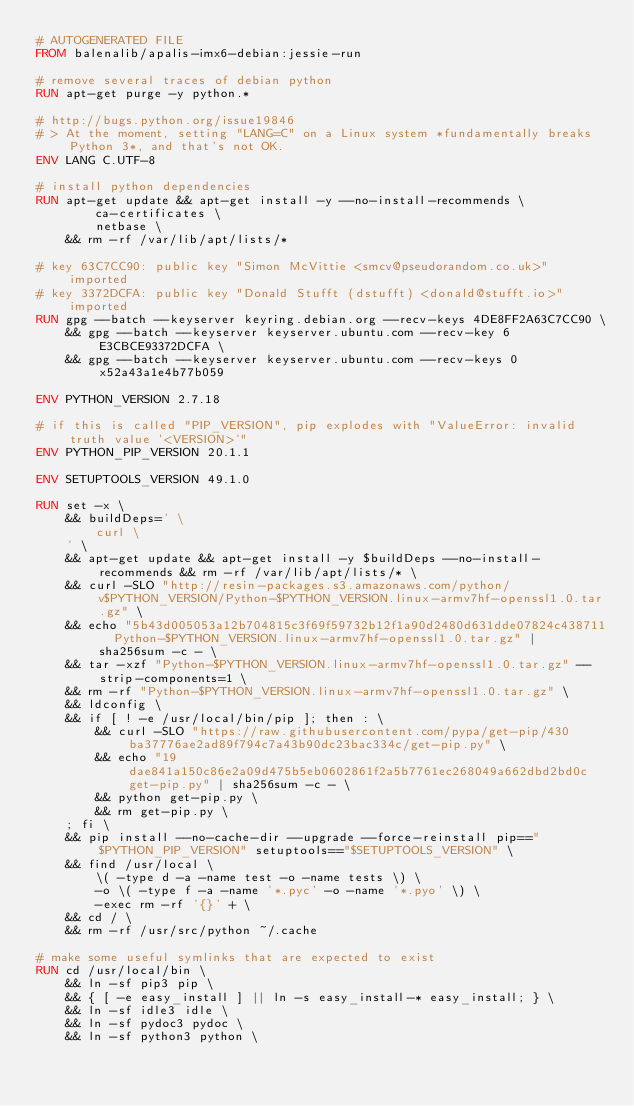Convert code to text. <code><loc_0><loc_0><loc_500><loc_500><_Dockerfile_># AUTOGENERATED FILE
FROM balenalib/apalis-imx6-debian:jessie-run

# remove several traces of debian python
RUN apt-get purge -y python.*

# http://bugs.python.org/issue19846
# > At the moment, setting "LANG=C" on a Linux system *fundamentally breaks Python 3*, and that's not OK.
ENV LANG C.UTF-8

# install python dependencies
RUN apt-get update && apt-get install -y --no-install-recommends \
		ca-certificates \
		netbase \
	&& rm -rf /var/lib/apt/lists/*

# key 63C7CC90: public key "Simon McVittie <smcv@pseudorandom.co.uk>" imported
# key 3372DCFA: public key "Donald Stufft (dstufft) <donald@stufft.io>" imported
RUN gpg --batch --keyserver keyring.debian.org --recv-keys 4DE8FF2A63C7CC90 \
	&& gpg --batch --keyserver keyserver.ubuntu.com --recv-key 6E3CBCE93372DCFA \
	&& gpg --batch --keyserver keyserver.ubuntu.com --recv-keys 0x52a43a1e4b77b059

ENV PYTHON_VERSION 2.7.18

# if this is called "PIP_VERSION", pip explodes with "ValueError: invalid truth value '<VERSION>'"
ENV PYTHON_PIP_VERSION 20.1.1

ENV SETUPTOOLS_VERSION 49.1.0

RUN set -x \
	&& buildDeps=' \
		curl \
	' \
	&& apt-get update && apt-get install -y $buildDeps --no-install-recommends && rm -rf /var/lib/apt/lists/* \
	&& curl -SLO "http://resin-packages.s3.amazonaws.com/python/v$PYTHON_VERSION/Python-$PYTHON_VERSION.linux-armv7hf-openssl1.0.tar.gz" \
	&& echo "5b43d005053a12b704815c3f69f59732b12f1a90d2480d631dde07824c438711  Python-$PYTHON_VERSION.linux-armv7hf-openssl1.0.tar.gz" | sha256sum -c - \
	&& tar -xzf "Python-$PYTHON_VERSION.linux-armv7hf-openssl1.0.tar.gz" --strip-components=1 \
	&& rm -rf "Python-$PYTHON_VERSION.linux-armv7hf-openssl1.0.tar.gz" \
	&& ldconfig \
	&& if [ ! -e /usr/local/bin/pip ]; then : \
		&& curl -SLO "https://raw.githubusercontent.com/pypa/get-pip/430ba37776ae2ad89f794c7a43b90dc23bac334c/get-pip.py" \
		&& echo "19dae841a150c86e2a09d475b5eb0602861f2a5b7761ec268049a662dbd2bd0c  get-pip.py" | sha256sum -c - \
		&& python get-pip.py \
		&& rm get-pip.py \
	; fi \
	&& pip install --no-cache-dir --upgrade --force-reinstall pip=="$PYTHON_PIP_VERSION" setuptools=="$SETUPTOOLS_VERSION" \
	&& find /usr/local \
		\( -type d -a -name test -o -name tests \) \
		-o \( -type f -a -name '*.pyc' -o -name '*.pyo' \) \
		-exec rm -rf '{}' + \
	&& cd / \
	&& rm -rf /usr/src/python ~/.cache

# make some useful symlinks that are expected to exist
RUN cd /usr/local/bin \
	&& ln -sf pip3 pip \
	&& { [ -e easy_install ] || ln -s easy_install-* easy_install; } \
	&& ln -sf idle3 idle \
	&& ln -sf pydoc3 pydoc \
	&& ln -sf python3 python \</code> 